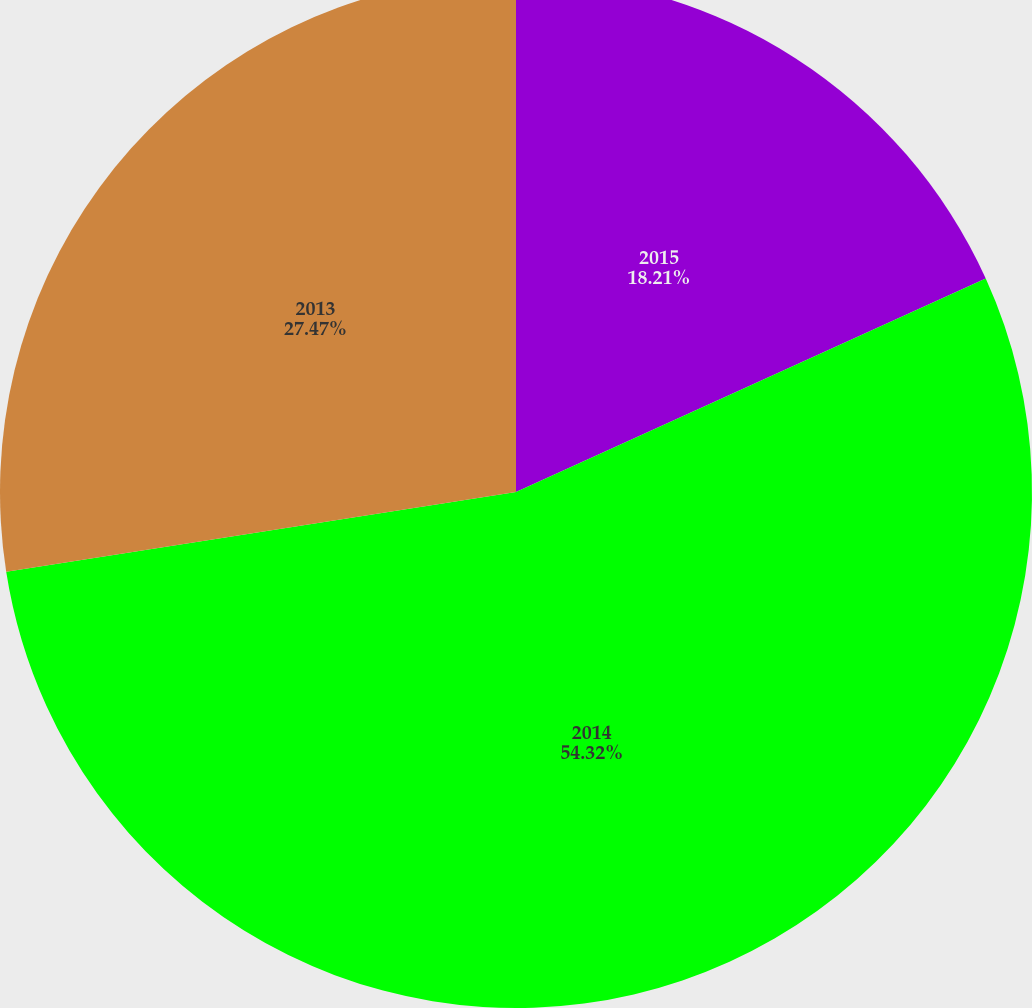Convert chart. <chart><loc_0><loc_0><loc_500><loc_500><pie_chart><fcel>2015<fcel>2014<fcel>2013<nl><fcel>18.21%<fcel>54.32%<fcel>27.47%<nl></chart> 